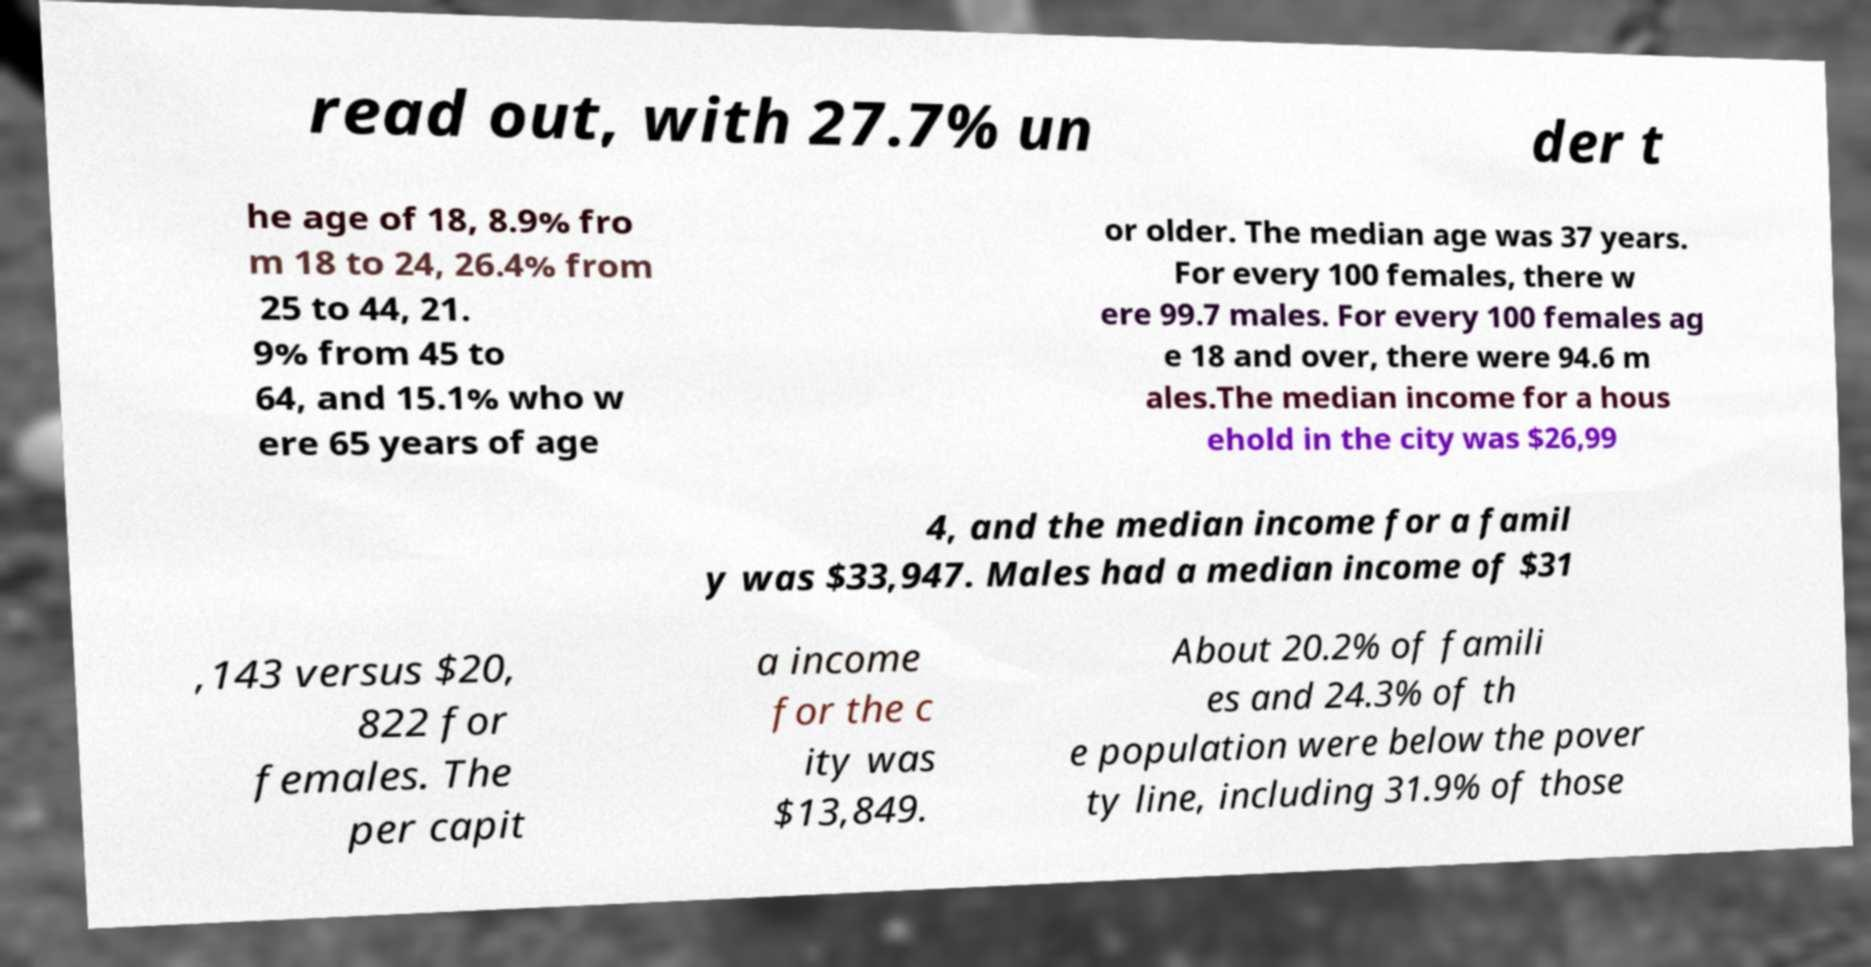I need the written content from this picture converted into text. Can you do that? read out, with 27.7% un der t he age of 18, 8.9% fro m 18 to 24, 26.4% from 25 to 44, 21. 9% from 45 to 64, and 15.1% who w ere 65 years of age or older. The median age was 37 years. For every 100 females, there w ere 99.7 males. For every 100 females ag e 18 and over, there were 94.6 m ales.The median income for a hous ehold in the city was $26,99 4, and the median income for a famil y was $33,947. Males had a median income of $31 ,143 versus $20, 822 for females. The per capit a income for the c ity was $13,849. About 20.2% of famili es and 24.3% of th e population were below the pover ty line, including 31.9% of those 